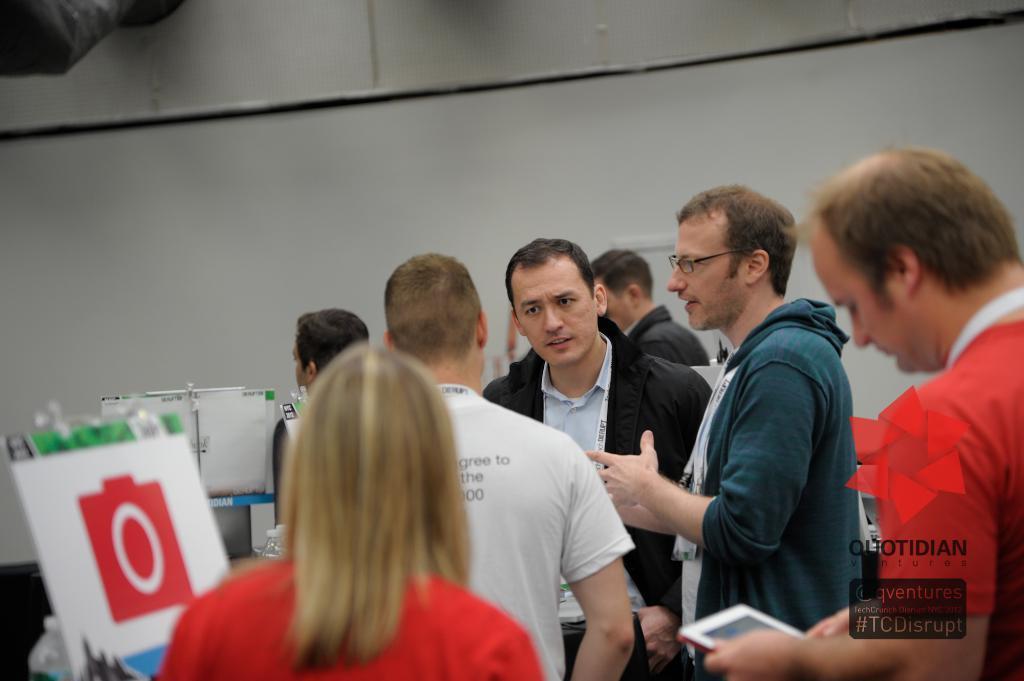Describe this image in one or two sentences. This image consists of many persons and we can see the boats and we can see the boards. In the background, there is a wall. 